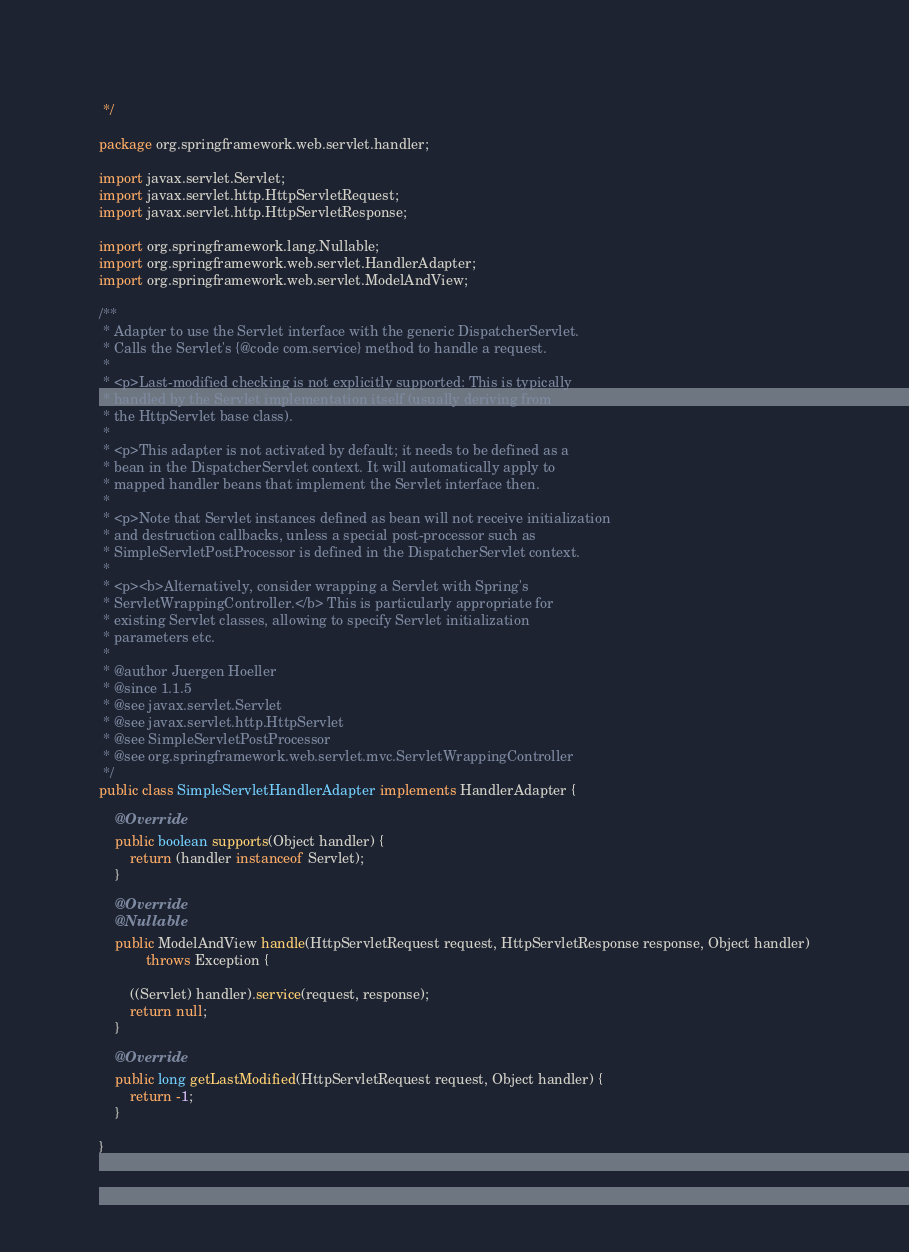<code> <loc_0><loc_0><loc_500><loc_500><_Java_> */

package org.springframework.web.servlet.handler;

import javax.servlet.Servlet;
import javax.servlet.http.HttpServletRequest;
import javax.servlet.http.HttpServletResponse;

import org.springframework.lang.Nullable;
import org.springframework.web.servlet.HandlerAdapter;
import org.springframework.web.servlet.ModelAndView;

/**
 * Adapter to use the Servlet interface with the generic DispatcherServlet.
 * Calls the Servlet's {@code com.service} method to handle a request.
 *
 * <p>Last-modified checking is not explicitly supported: This is typically
 * handled by the Servlet implementation itself (usually deriving from
 * the HttpServlet base class).
 *
 * <p>This adapter is not activated by default; it needs to be defined as a
 * bean in the DispatcherServlet context. It will automatically apply to
 * mapped handler beans that implement the Servlet interface then.
 *
 * <p>Note that Servlet instances defined as bean will not receive initialization
 * and destruction callbacks, unless a special post-processor such as
 * SimpleServletPostProcessor is defined in the DispatcherServlet context.
 *
 * <p><b>Alternatively, consider wrapping a Servlet with Spring's
 * ServletWrappingController.</b> This is particularly appropriate for
 * existing Servlet classes, allowing to specify Servlet initialization
 * parameters etc.
 *
 * @author Juergen Hoeller
 * @since 1.1.5
 * @see javax.servlet.Servlet
 * @see javax.servlet.http.HttpServlet
 * @see SimpleServletPostProcessor
 * @see org.springframework.web.servlet.mvc.ServletWrappingController
 */
public class SimpleServletHandlerAdapter implements HandlerAdapter {

	@Override
	public boolean supports(Object handler) {
		return (handler instanceof Servlet);
	}

	@Override
	@Nullable
	public ModelAndView handle(HttpServletRequest request, HttpServletResponse response, Object handler)
			throws Exception {

		((Servlet) handler).service(request, response);
		return null;
	}

	@Override
	public long getLastModified(HttpServletRequest request, Object handler) {
		return -1;
	}

}
</code> 